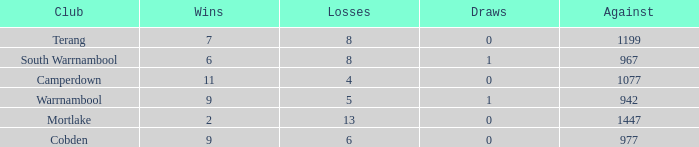What's the number of losses when the wins were more than 11 and had 0 draws? 0.0. 